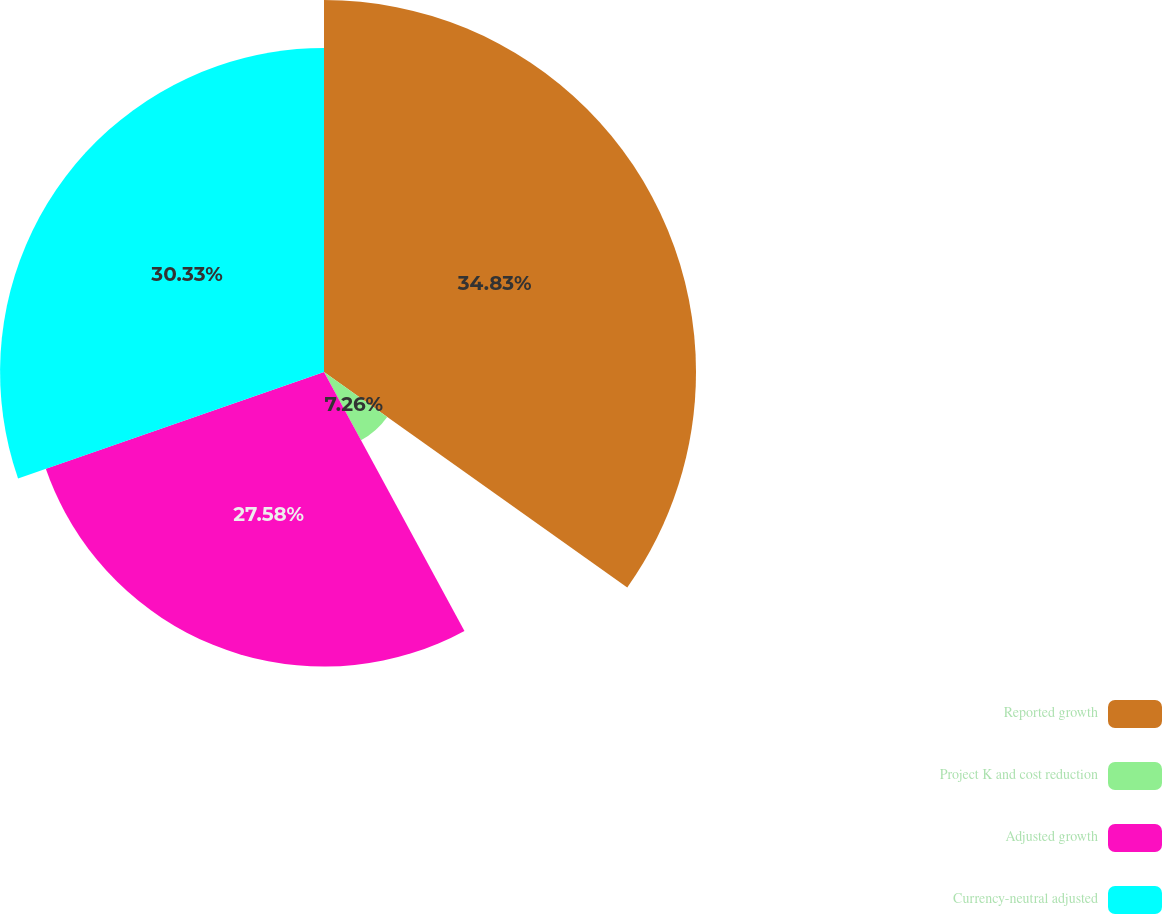<chart> <loc_0><loc_0><loc_500><loc_500><pie_chart><fcel>Reported growth<fcel>Project K and cost reduction<fcel>Adjusted growth<fcel>Currency-neutral adjusted<nl><fcel>34.83%<fcel>7.26%<fcel>27.58%<fcel>30.33%<nl></chart> 